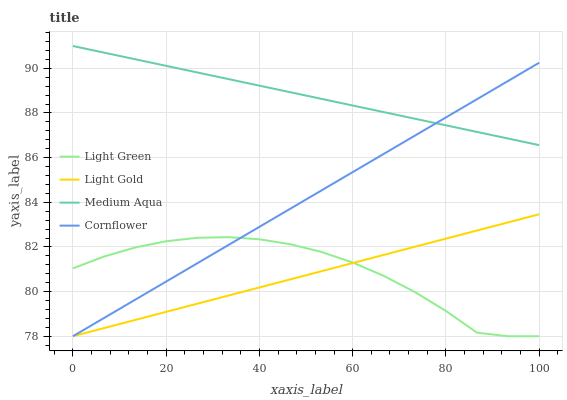Does Light Gold have the minimum area under the curve?
Answer yes or no. Yes. Does Medium Aqua have the maximum area under the curve?
Answer yes or no. Yes. Does Light Green have the minimum area under the curve?
Answer yes or no. No. Does Light Green have the maximum area under the curve?
Answer yes or no. No. Is Light Gold the smoothest?
Answer yes or no. Yes. Is Light Green the roughest?
Answer yes or no. Yes. Is Light Green the smoothest?
Answer yes or no. No. Is Light Gold the roughest?
Answer yes or no. No. Does Light Gold have the highest value?
Answer yes or no. No. Is Light Gold less than Medium Aqua?
Answer yes or no. Yes. Is Medium Aqua greater than Light Gold?
Answer yes or no. Yes. Does Light Gold intersect Medium Aqua?
Answer yes or no. No. 